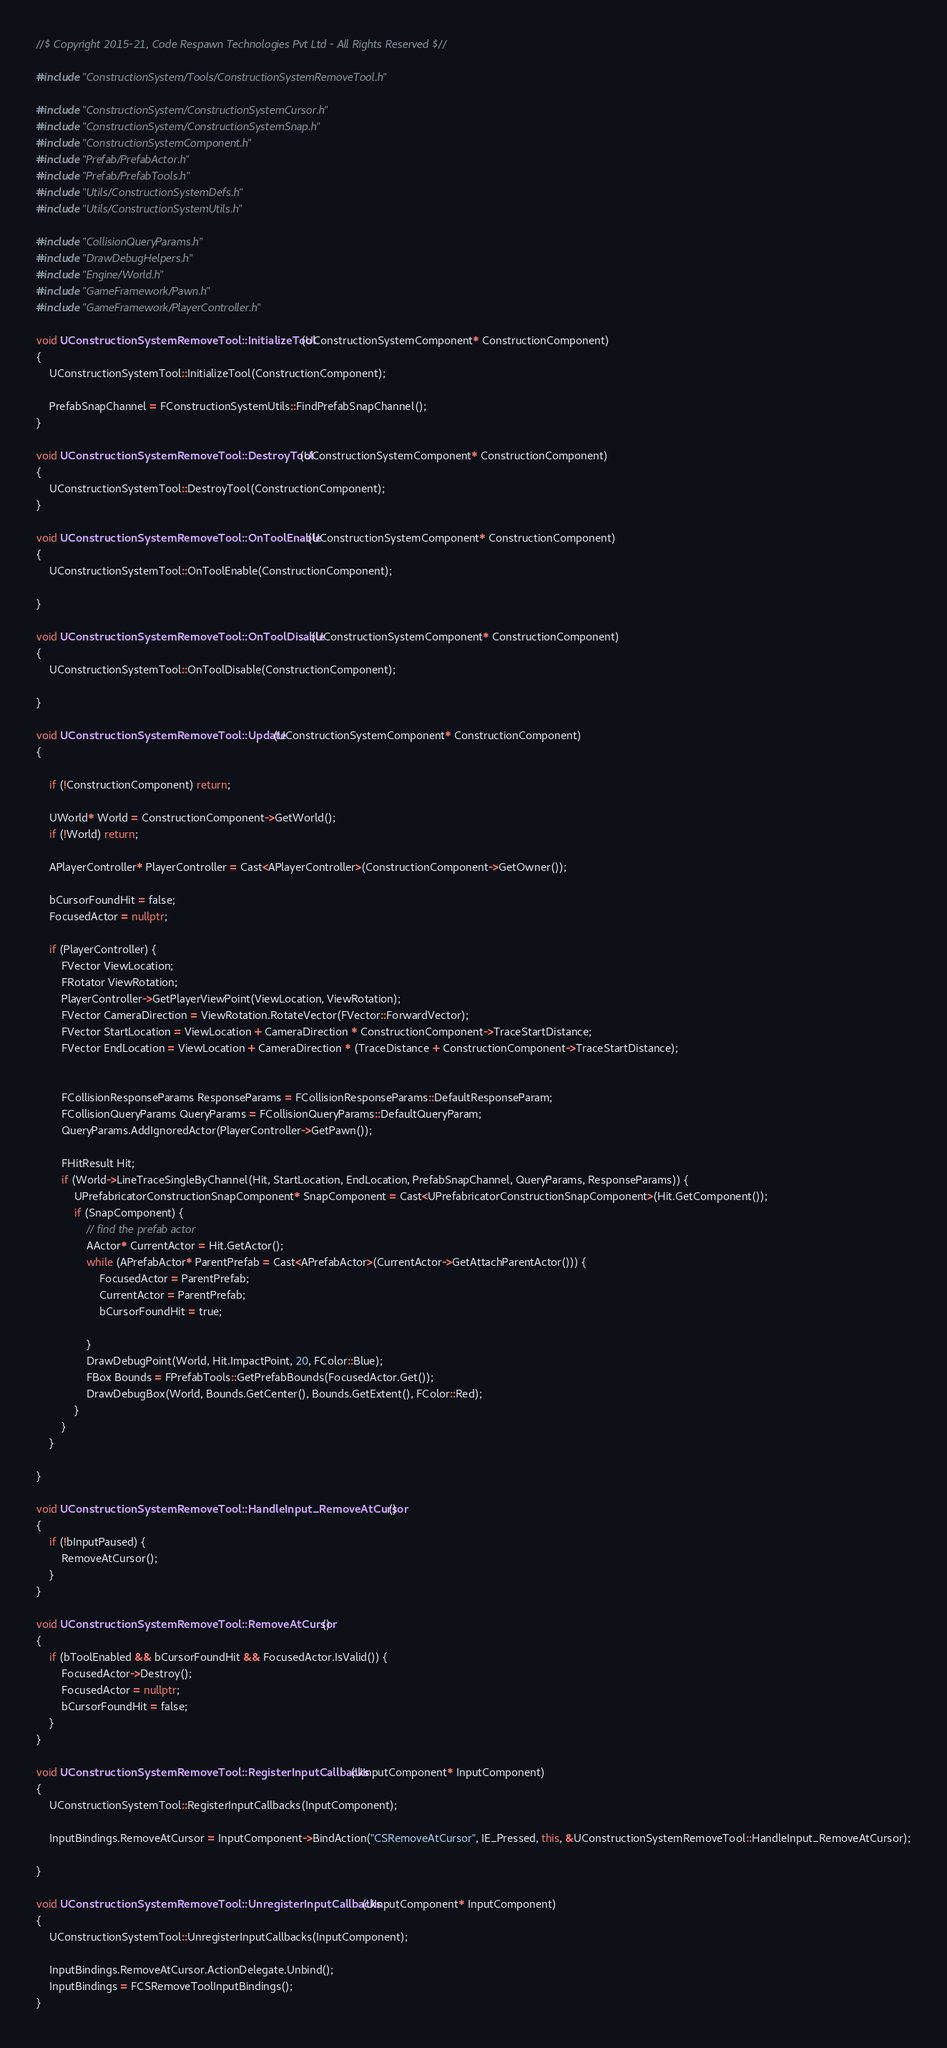<code> <loc_0><loc_0><loc_500><loc_500><_C++_>//$ Copyright 2015-21, Code Respawn Technologies Pvt Ltd - All Rights Reserved $//

#include "ConstructionSystem/Tools/ConstructionSystemRemoveTool.h"

#include "ConstructionSystem/ConstructionSystemCursor.h"
#include "ConstructionSystem/ConstructionSystemSnap.h"
#include "ConstructionSystemComponent.h"
#include "Prefab/PrefabActor.h"
#include "Prefab/PrefabTools.h"
#include "Utils/ConstructionSystemDefs.h"
#include "Utils/ConstructionSystemUtils.h"

#include "CollisionQueryParams.h"
#include "DrawDebugHelpers.h"
#include "Engine/World.h"
#include "GameFramework/Pawn.h"
#include "GameFramework/PlayerController.h"

void UConstructionSystemRemoveTool::InitializeTool(UConstructionSystemComponent* ConstructionComponent)
{
	UConstructionSystemTool::InitializeTool(ConstructionComponent);

	PrefabSnapChannel = FConstructionSystemUtils::FindPrefabSnapChannel();
}

void UConstructionSystemRemoveTool::DestroyTool(UConstructionSystemComponent* ConstructionComponent)
{
	UConstructionSystemTool::DestroyTool(ConstructionComponent);
}

void UConstructionSystemRemoveTool::OnToolEnable(UConstructionSystemComponent* ConstructionComponent)
{
	UConstructionSystemTool::OnToolEnable(ConstructionComponent);

}

void UConstructionSystemRemoveTool::OnToolDisable(UConstructionSystemComponent* ConstructionComponent)
{
	UConstructionSystemTool::OnToolDisable(ConstructionComponent);

}

void UConstructionSystemRemoveTool::Update(UConstructionSystemComponent* ConstructionComponent)
{

	if (!ConstructionComponent) return;

	UWorld* World = ConstructionComponent->GetWorld();
	if (!World) return;

	APlayerController* PlayerController = Cast<APlayerController>(ConstructionComponent->GetOwner());

	bCursorFoundHit = false;
	FocusedActor = nullptr;

	if (PlayerController) {
		FVector ViewLocation;
		FRotator ViewRotation;
		PlayerController->GetPlayerViewPoint(ViewLocation, ViewRotation);
		FVector CameraDirection = ViewRotation.RotateVector(FVector::ForwardVector);
		FVector StartLocation = ViewLocation + CameraDirection * ConstructionComponent->TraceStartDistance;
		FVector EndLocation = ViewLocation + CameraDirection * (TraceDistance + ConstructionComponent->TraceStartDistance);


		FCollisionResponseParams ResponseParams = FCollisionResponseParams::DefaultResponseParam;
		FCollisionQueryParams QueryParams = FCollisionQueryParams::DefaultQueryParam;
		QueryParams.AddIgnoredActor(PlayerController->GetPawn());

		FHitResult Hit;
		if (World->LineTraceSingleByChannel(Hit, StartLocation, EndLocation, PrefabSnapChannel, QueryParams, ResponseParams)) {
			UPrefabricatorConstructionSnapComponent* SnapComponent = Cast<UPrefabricatorConstructionSnapComponent>(Hit.GetComponent());
			if (SnapComponent) {
				// find the prefab actor
				AActor* CurrentActor = Hit.GetActor();
				while (APrefabActor* ParentPrefab = Cast<APrefabActor>(CurrentActor->GetAttachParentActor())) {
					FocusedActor = ParentPrefab;
					CurrentActor = ParentPrefab;
					bCursorFoundHit = true;

				}
				DrawDebugPoint(World, Hit.ImpactPoint, 20, FColor::Blue);
				FBox Bounds = FPrefabTools::GetPrefabBounds(FocusedActor.Get());
				DrawDebugBox(World, Bounds.GetCenter(), Bounds.GetExtent(), FColor::Red);
			}
		}
	}

}

void UConstructionSystemRemoveTool::HandleInput_RemoveAtCursor()
{
	if (!bInputPaused) {
		RemoveAtCursor();
	}
}

void UConstructionSystemRemoveTool::RemoveAtCursor()
{
	if (bToolEnabled && bCursorFoundHit && FocusedActor.IsValid()) {
		FocusedActor->Destroy();
		FocusedActor = nullptr;
		bCursorFoundHit = false;
	}
}

void UConstructionSystemRemoveTool::RegisterInputCallbacks(UInputComponent* InputComponent)
{
	UConstructionSystemTool::RegisterInputCallbacks(InputComponent);

	InputBindings.RemoveAtCursor = InputComponent->BindAction("CSRemoveAtCursor", IE_Pressed, this, &UConstructionSystemRemoveTool::HandleInput_RemoveAtCursor);

}

void UConstructionSystemRemoveTool::UnregisterInputCallbacks(UInputComponent* InputComponent)
{
	UConstructionSystemTool::UnregisterInputCallbacks(InputComponent);

	InputBindings.RemoveAtCursor.ActionDelegate.Unbind();
	InputBindings = FCSRemoveToolInputBindings();
}

</code> 